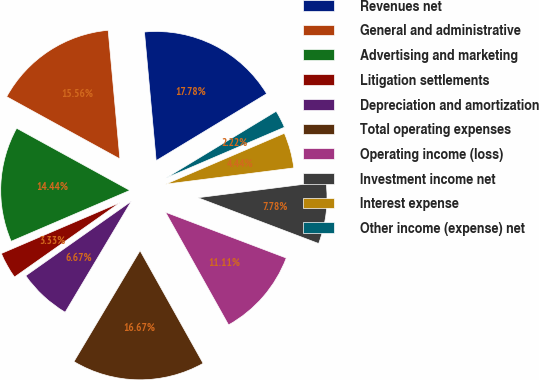Convert chart. <chart><loc_0><loc_0><loc_500><loc_500><pie_chart><fcel>Revenues net<fcel>General and administrative<fcel>Advertising and marketing<fcel>Litigation settlements<fcel>Depreciation and amortization<fcel>Total operating expenses<fcel>Operating income (loss)<fcel>Investment income net<fcel>Interest expense<fcel>Other income (expense) net<nl><fcel>17.78%<fcel>15.56%<fcel>14.44%<fcel>3.33%<fcel>6.67%<fcel>16.67%<fcel>11.11%<fcel>7.78%<fcel>4.44%<fcel>2.22%<nl></chart> 